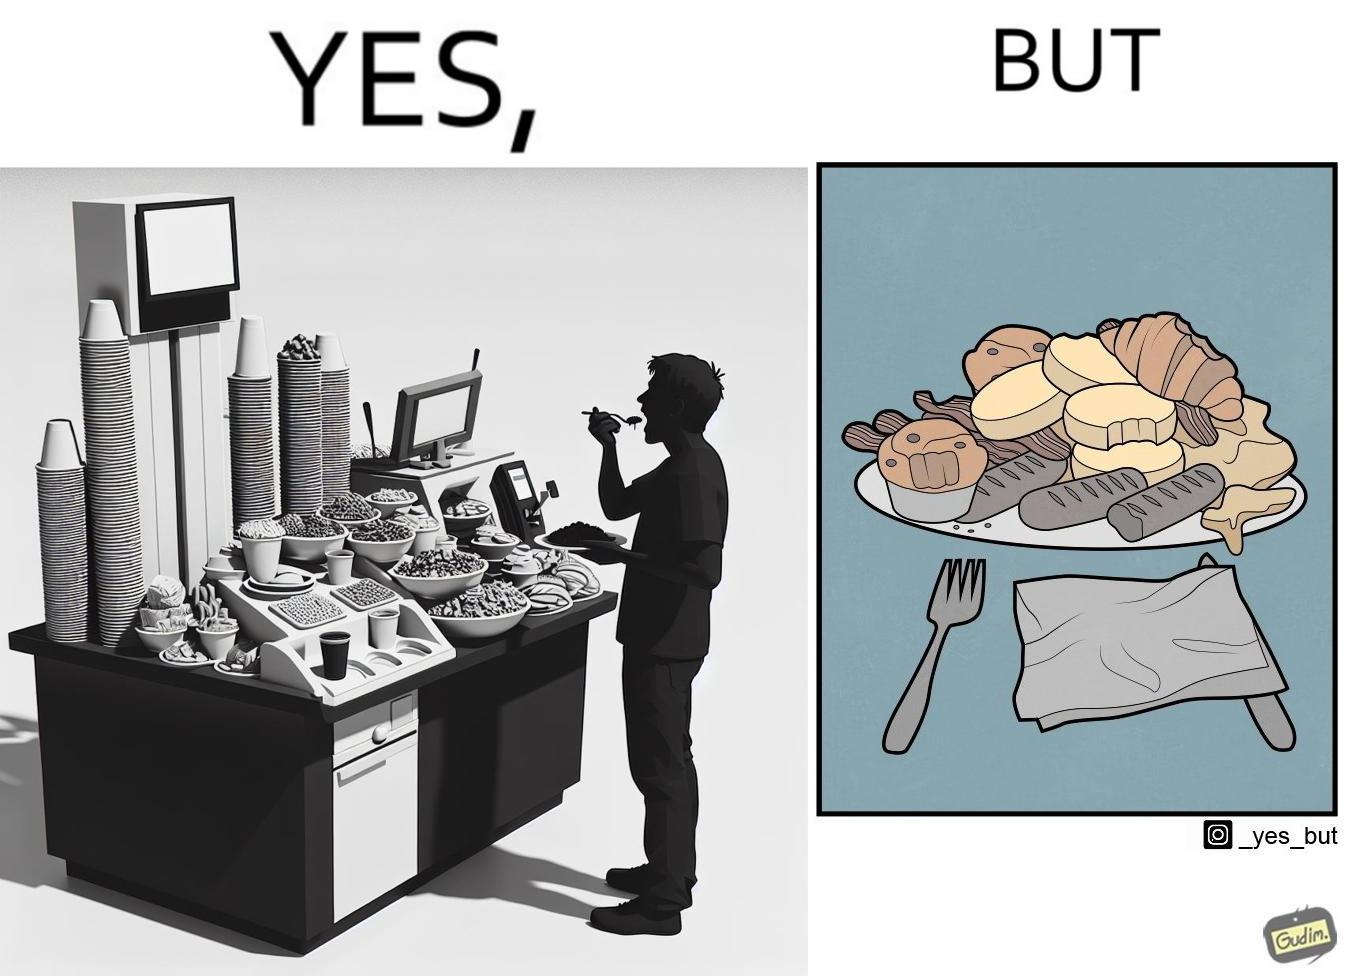Is this image satirical or non-satirical? Yes, this image is satirical. 